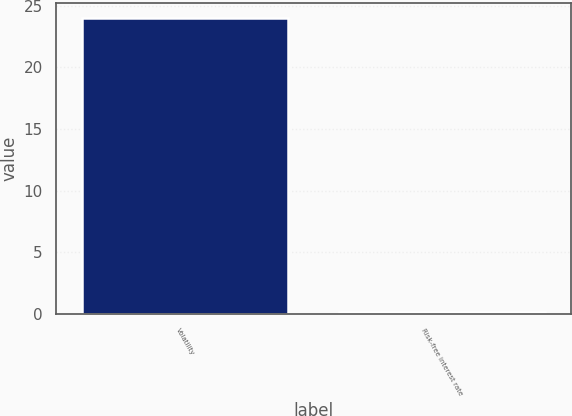Convert chart to OTSL. <chart><loc_0><loc_0><loc_500><loc_500><bar_chart><fcel>Volatility<fcel>Risk-free interest rate<nl><fcel>24<fcel>0.16<nl></chart> 